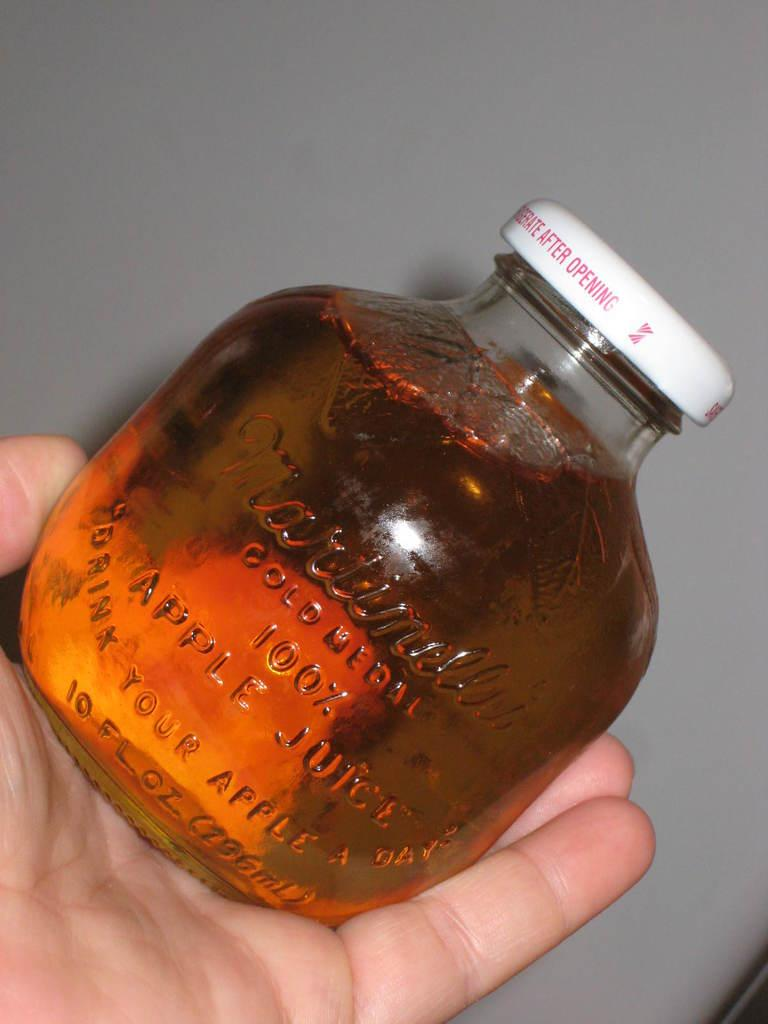What is contained in the bottle that is visible in the image? There is a bottle with liquid in the image. Who or what is holding the bottle in the image? A person's hand is holding the bottle. What can be seen in the background of the image? There is a wall visible in the background of the image. What type of library is depicted in the image? There is no library present in the image; it features a bottle with liquid and a person's hand holding it. How is the organization of the liquid in the bottle represented in the image? The image does not show the organization of the liquid in the bottle; it only shows the bottle and a person's hand holding it. 